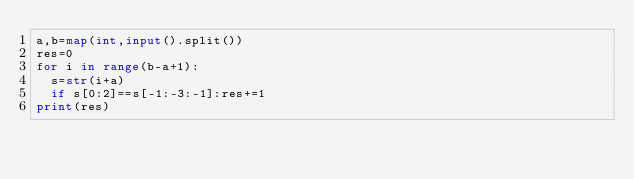<code> <loc_0><loc_0><loc_500><loc_500><_Python_>a,b=map(int,input().split())
res=0
for i in range(b-a+1):
  s=str(i+a)
  if s[0:2]==s[-1:-3:-1]:res+=1
print(res)</code> 